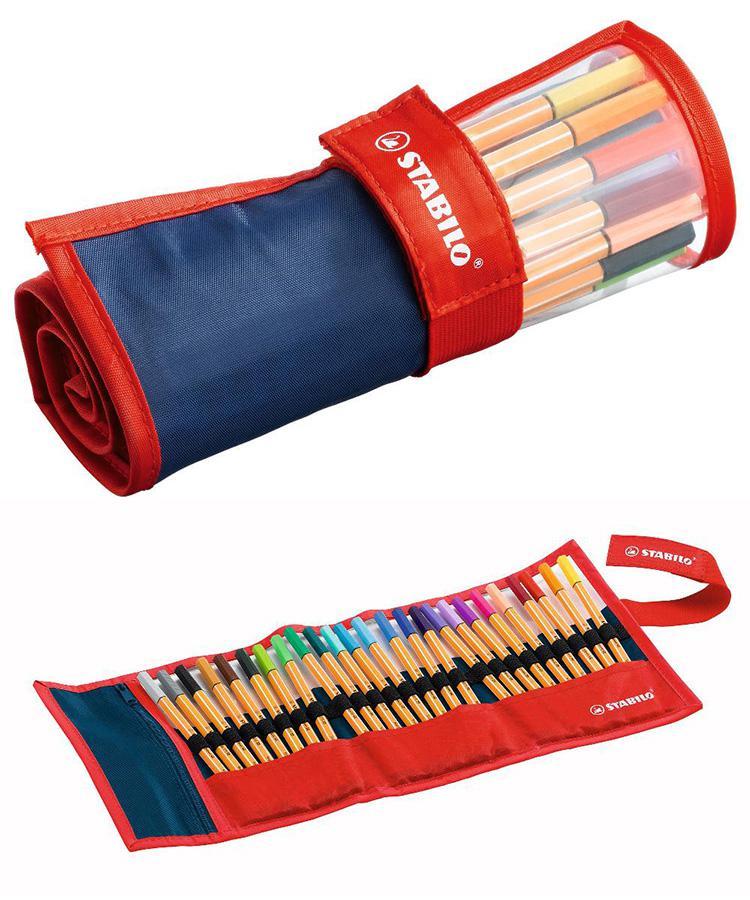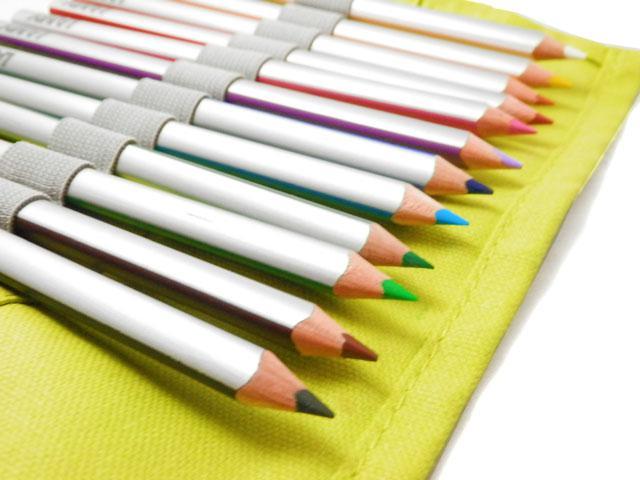The first image is the image on the left, the second image is the image on the right. Given the left and right images, does the statement "Some of the pencils are in a case made of metal." hold true? Answer yes or no. No. The first image is the image on the left, the second image is the image on the right. Given the left and right images, does the statement "The pencils in the image on the left are laying with their points facing down and slightly left." hold true? Answer yes or no. No. 